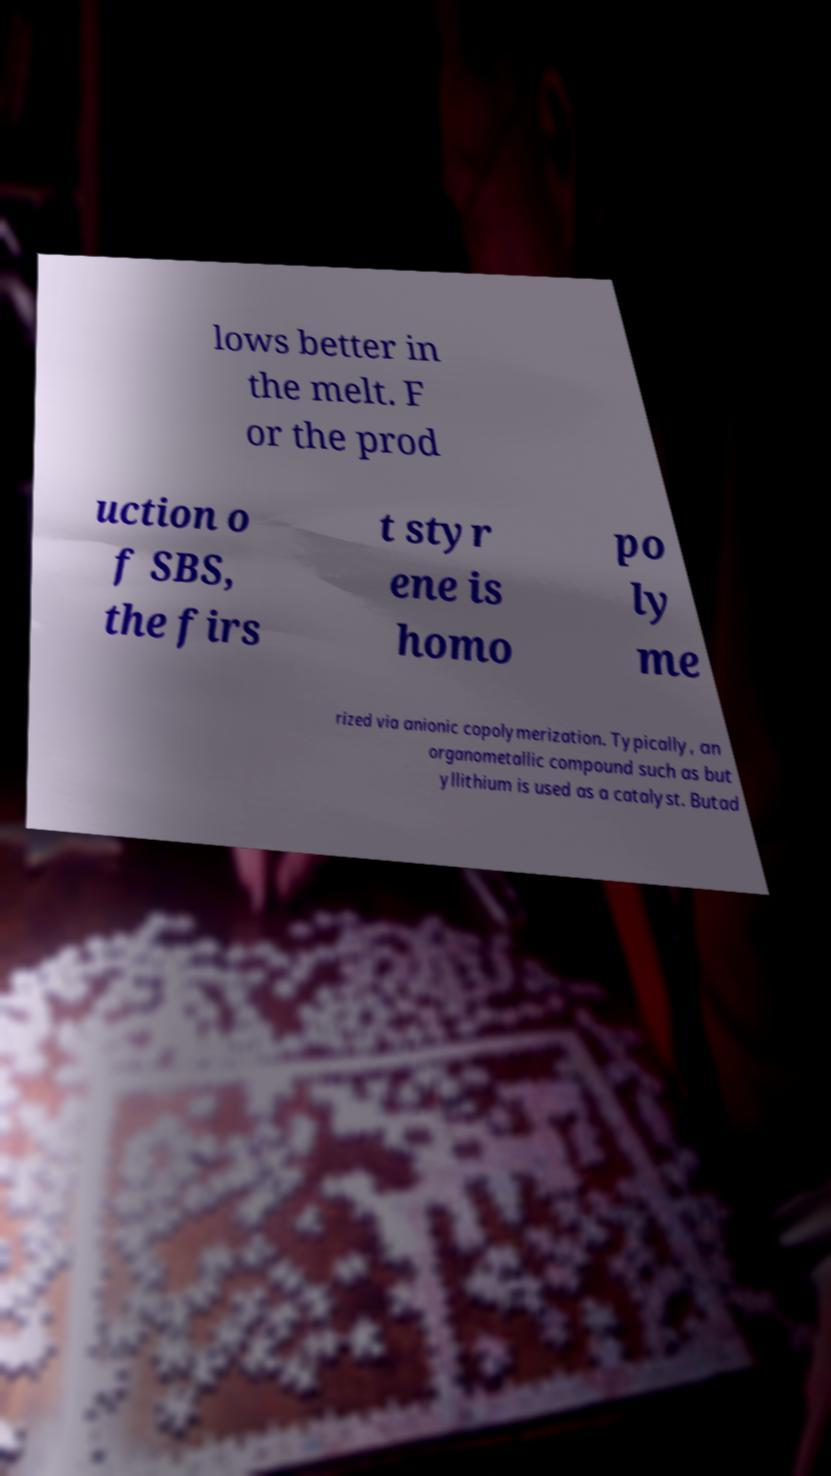Can you accurately transcribe the text from the provided image for me? lows better in the melt. F or the prod uction o f SBS, the firs t styr ene is homo po ly me rized via anionic copolymerization. Typically, an organometallic compound such as but yllithium is used as a catalyst. Butad 